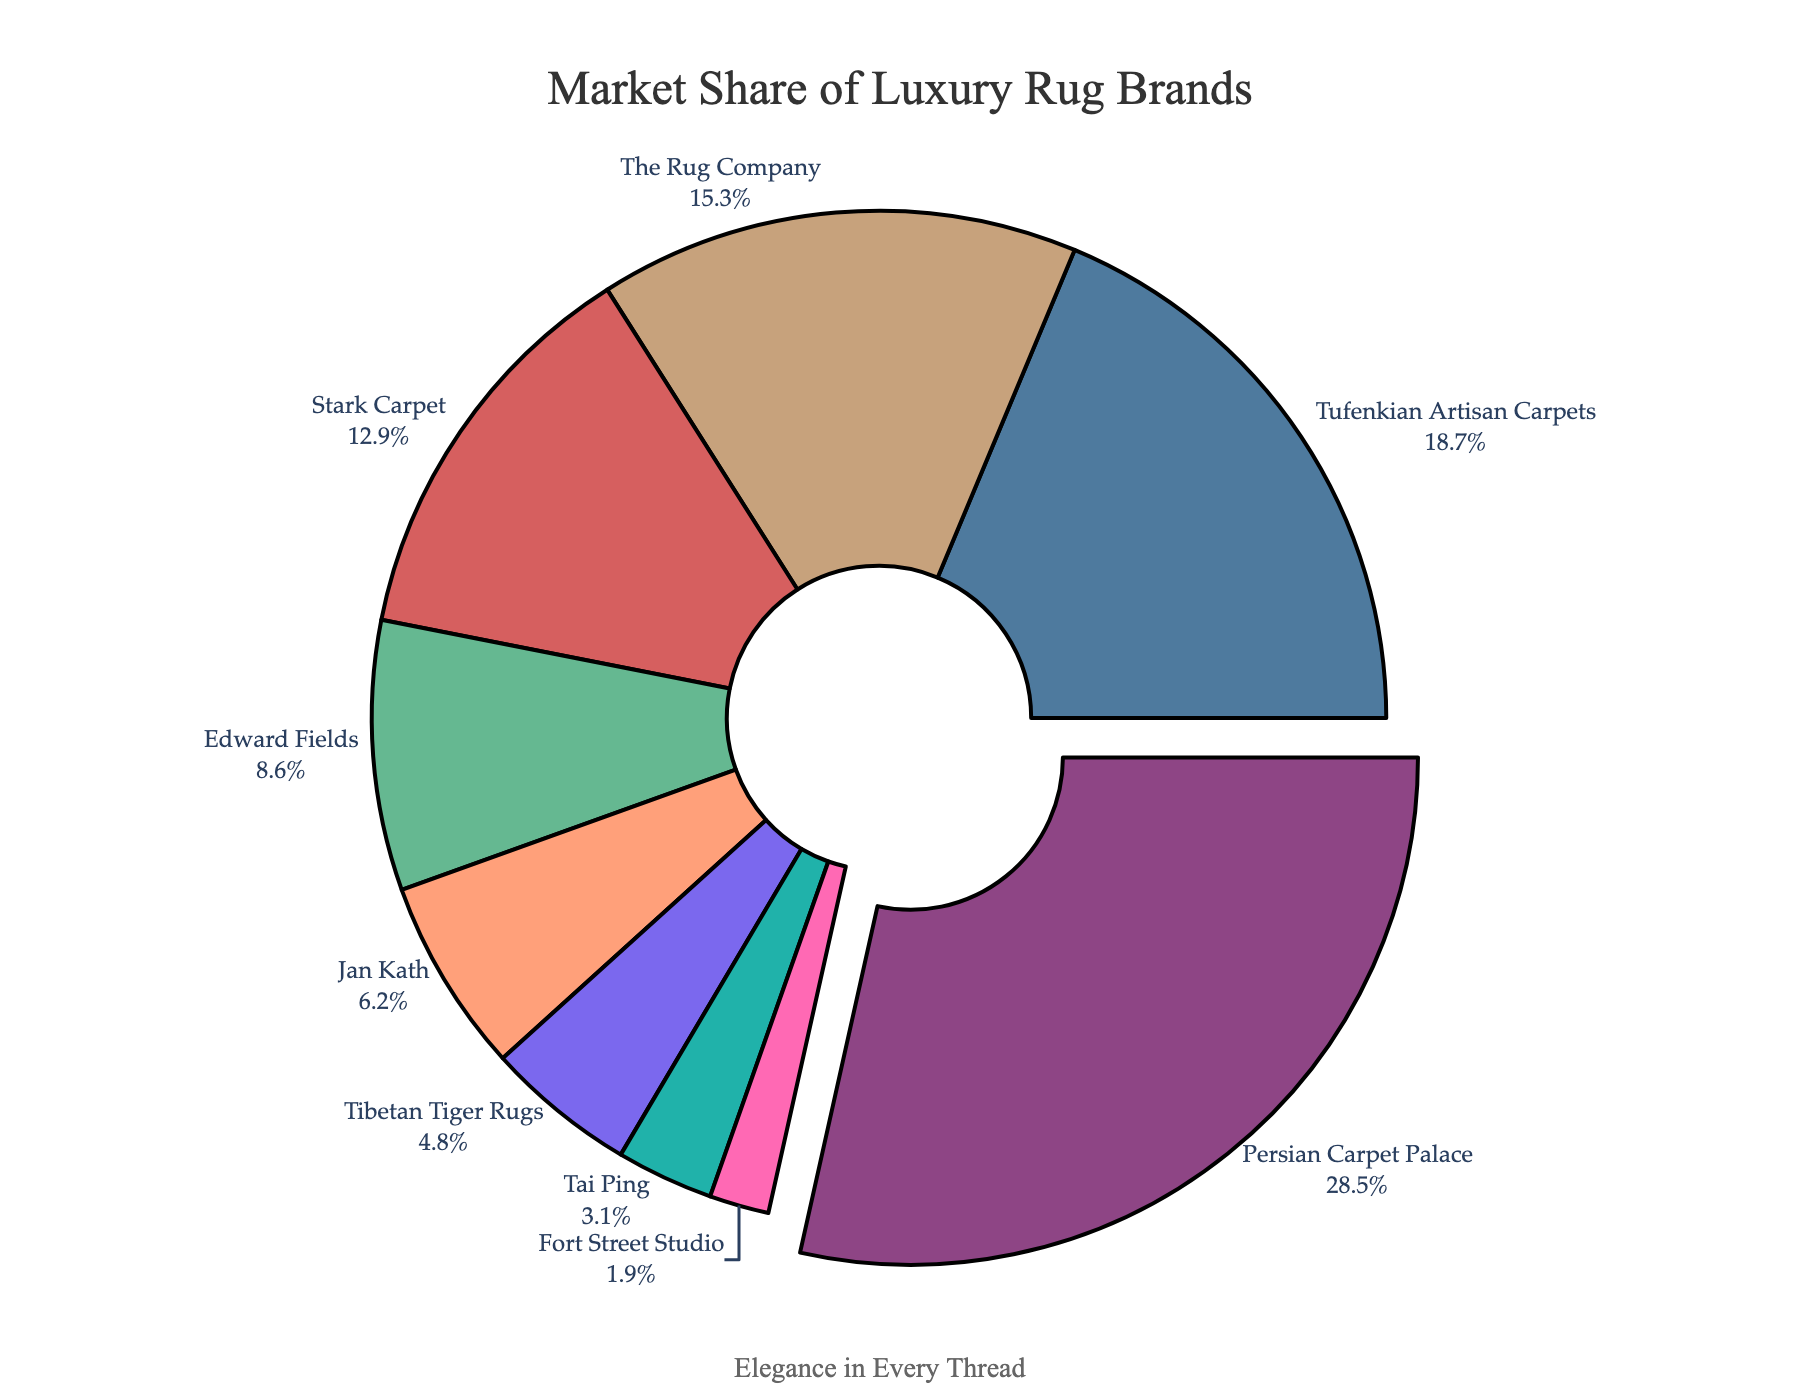How many brands have a market share greater than 10%? By looking at the pie chart, we can see which brands have segments that are larger than 10%. These brands are Persian Carpet Palace, Tufenkian Artisan Carpets, The Rug Company, and Stark Carpet. We count these brands.
Answer: 4 Which brand has the largest market share? The largest segment in the pie chart corresponds to Persian Carpet Palace.
Answer: Persian Carpet Palace What is the sum of market shares of the three least represented brands? By identifying the three smallest segments in the pie chart, we find Fort Street Studio (1.9%), Tai Ping (3.1%), and Tibetan Tiger Rugs (4.8%). Summing these percentages: 1.9 + 3.1 + 4.8 = 9.8%.
Answer: 9.8% What percentage of the market do brands other than Persian Carpet Palace, Tufenkian Artisan Carpets, and The Rug Company hold? Add up the market shares of all brands except Persian Carpet Palace (28.5%), Tufenkian Artisan Carpets (18.7%), and The Rug Company (15.3%): 12.9 + 8.6 + 6.2 + 4.8 + 3.1 + 1.9 = 37.5%.
Answer: 37.5% Which brand has a market share closest to 10%? The brand with a market share closest to 10% is Edward Fields with a market share of 8.6%.
Answer: Edward Fields What is the combined market share of the two smallest brands? The two smallest brands are Fort Street Studio (1.9%) and Tai Ping (3.1%). Adding these together gives 1.9 + 3.1 = 5%.
Answer: 5% Which is the second largest brand in terms of market share? The second largest segment in the pie chart belongs to Tufenkian Artisan Carpets with a market share of 18.7%.
Answer: Tufenkian Artisan Carpets How does the market share of Edward Fields compare to Jan Kath? Edward Fields has a market share of 8.6%, while Jan Kath holds 6.2%. Edward Fields' market share is greater than Jan Kath's.
Answer: Edward Fields > Jan Kath What is the average market share of Stark Carpet, Edward Fields, and Jan Kath? Sum the market shares of Stark Carpet (12.9%), Edward Fields (8.6%), and Jan Kath (6.2%) which results in 12.9 + 8.6 + 6.2 = 27.7%. Divide this by 3 because we are finding the average: 27.7 / 3 = 9.23%.
Answer: 9.23% 